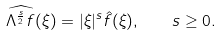Convert formula to latex. <formula><loc_0><loc_0><loc_500><loc_500>\widehat { \Lambda ^ { \frac { s } { 2 } } f } ( \xi ) = | \xi | ^ { s } \hat { f } ( \xi ) , \quad s \geq 0 .</formula> 